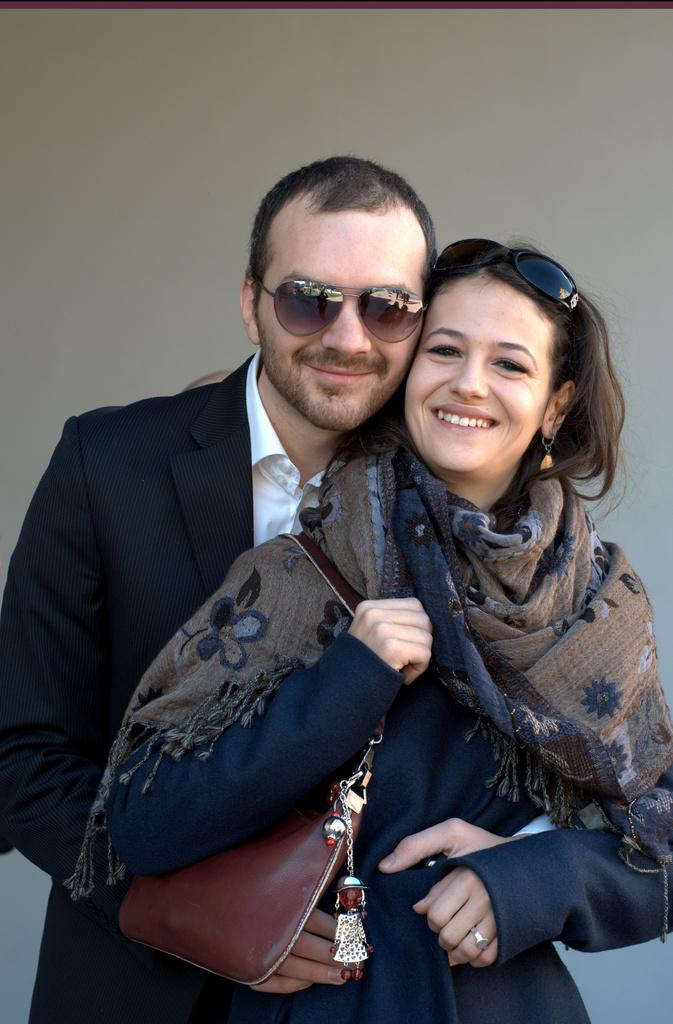How many people are in the image? There are two persons in the image. What are the persons doing in the image? The persons are standing and smiling. What can be seen in the background of the image? There is a wall in the background of the image. What type of metal box is visible on the wall in the image? There is no metal box present on the wall in the image. 